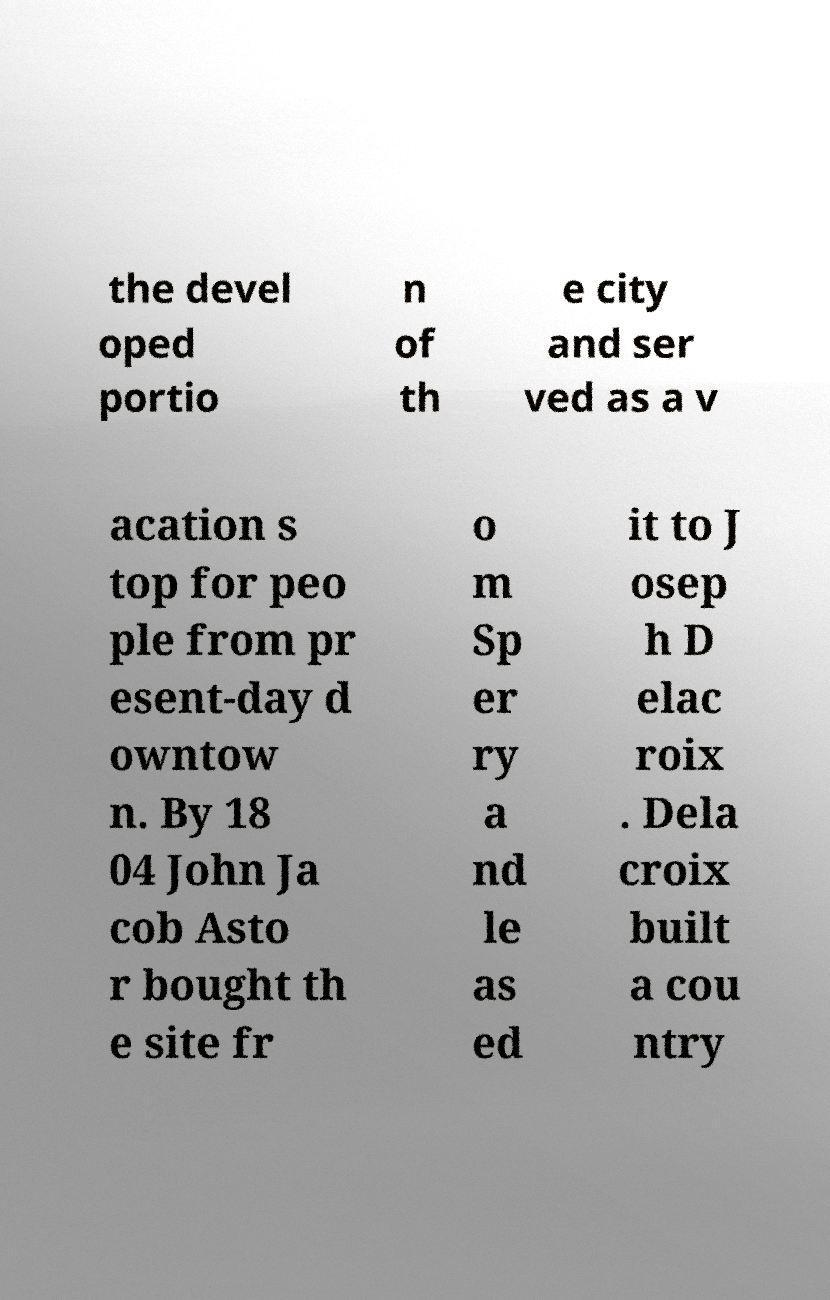For documentation purposes, I need the text within this image transcribed. Could you provide that? the devel oped portio n of th e city and ser ved as a v acation s top for peo ple from pr esent-day d owntow n. By 18 04 John Ja cob Asto r bought th e site fr o m Sp er ry a nd le as ed it to J osep h D elac roix . Dela croix built a cou ntry 